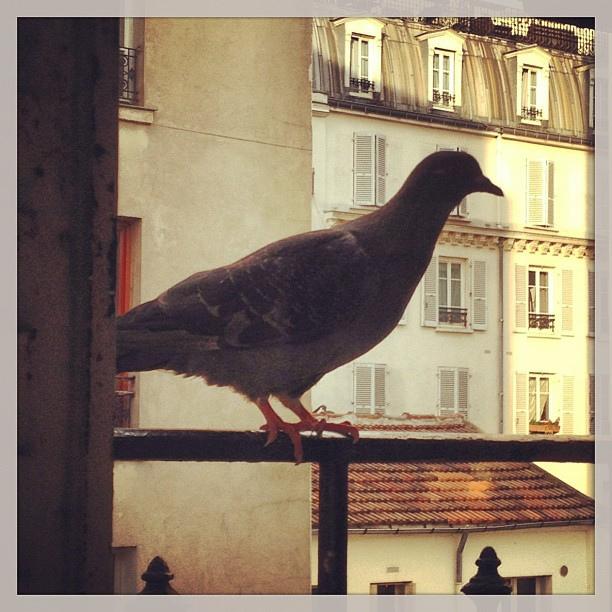How many birds can you see?
Answer briefly. 1. What color is the building?
Keep it brief. White. This is a close up photo of what type of animal?
Write a very short answer. Pigeon. 